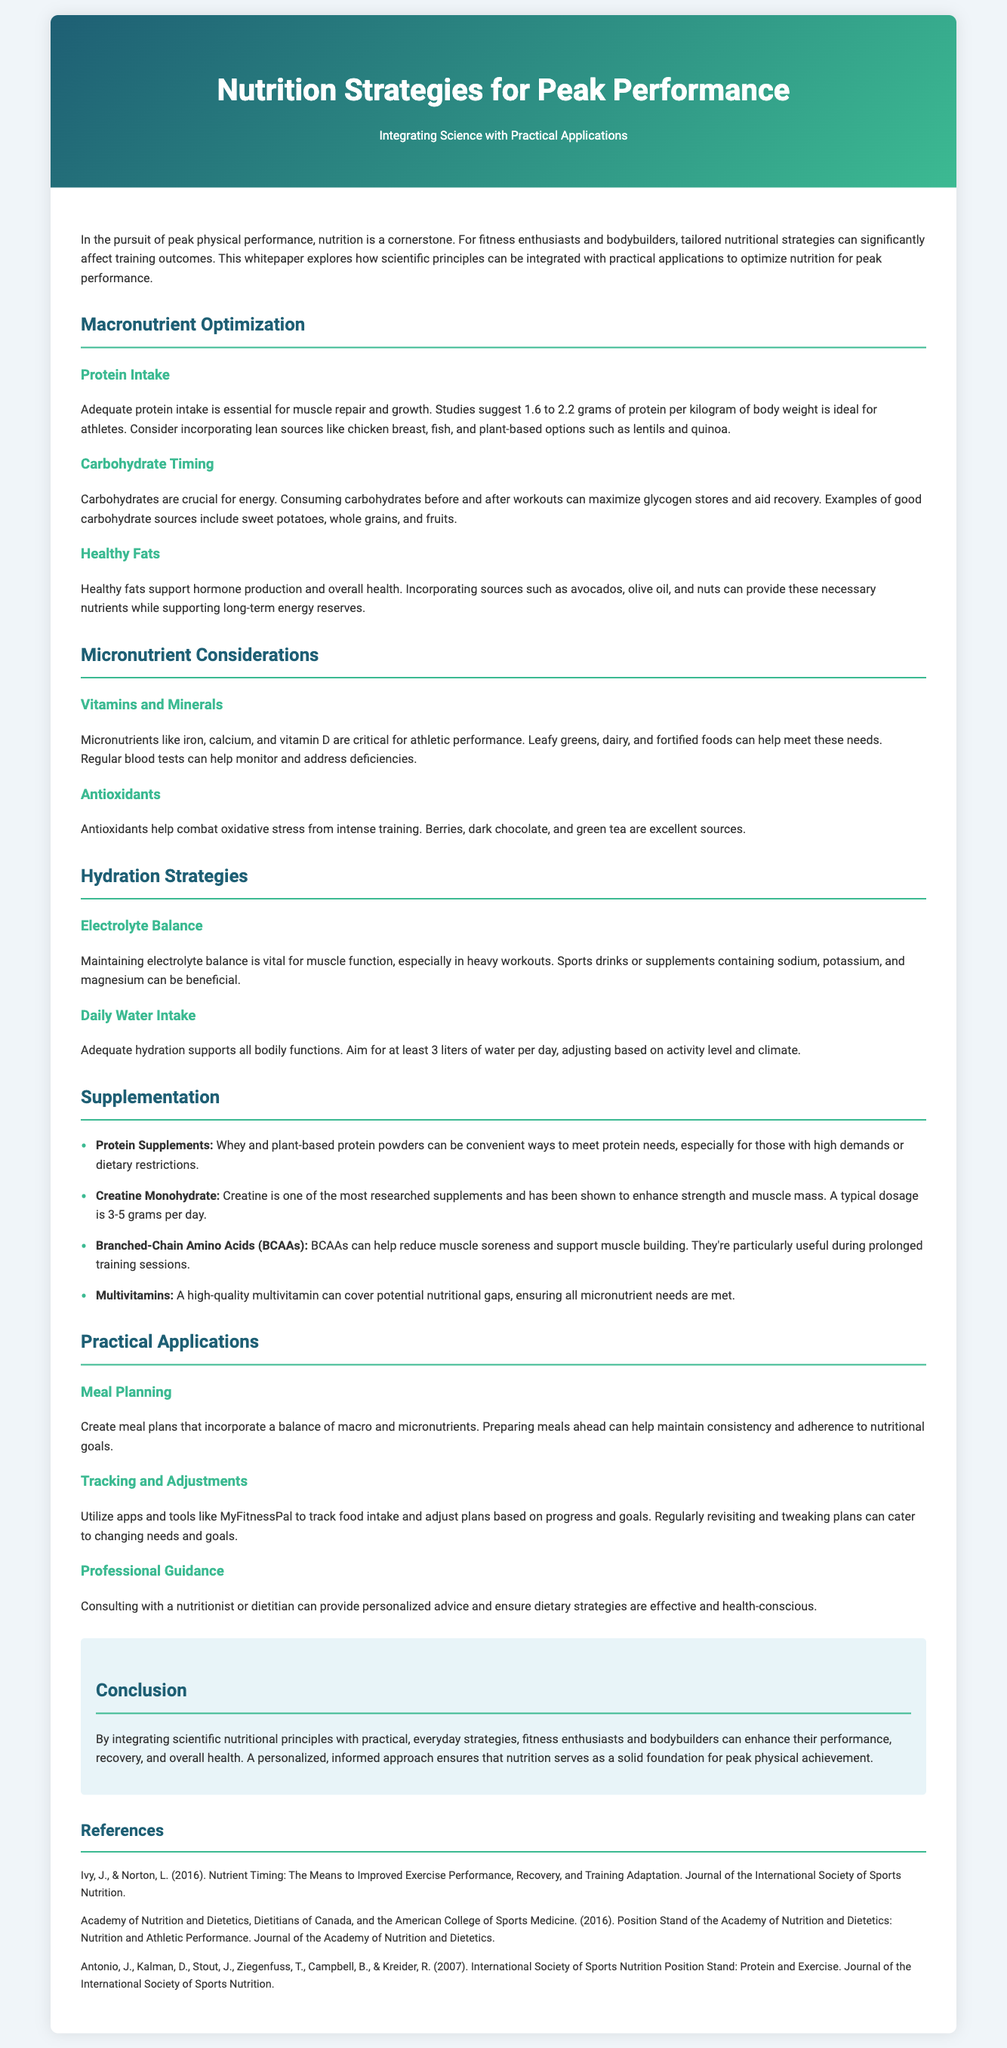What is the recommended protein intake for athletes? The document specifies that studies suggest 1.6 to 2.2 grams of protein per kilogram of body weight is ideal for athletes.
Answer: 1.6 to 2.2 grams per kilogram Which nutrient is crucial for energy before and after workouts? The document highlights carbohydrates as crucial for energy, especially when consumed before and after workouts.
Answer: Carbohydrates What type of fats supports hormone production? The document mentions that healthy fats support hormone production and overall health.
Answer: Healthy fats Name a food source high in antioxidants. The document lists berries, dark chocolate, and green tea as excellent sources of antioxidants.
Answer: Berries What is the typical dosage of creatine? The document states that a typical dosage of creatine is 3-5 grams per day.
Answer: 3-5 grams per day How many liters of water should one aim to drink daily? According to the document, one should aim for at least 3 liters of water per day.
Answer: At least 3 liters What is essential for muscle repair and growth? The document indicates that adequate protein intake is essential for muscle repair and growth.
Answer: Adequate protein intake What should be monitored to address vitamin deficiencies? Regular blood tests can help monitor and address deficiencies according to the document.
Answer: Regular blood tests Why is consulting a nutritionist recommended? The document suggests that consulting with a nutritionist or dietitian can provide personalized advice and ensure dietary strategies are effective and health-conscious.
Answer: Personalized advice 